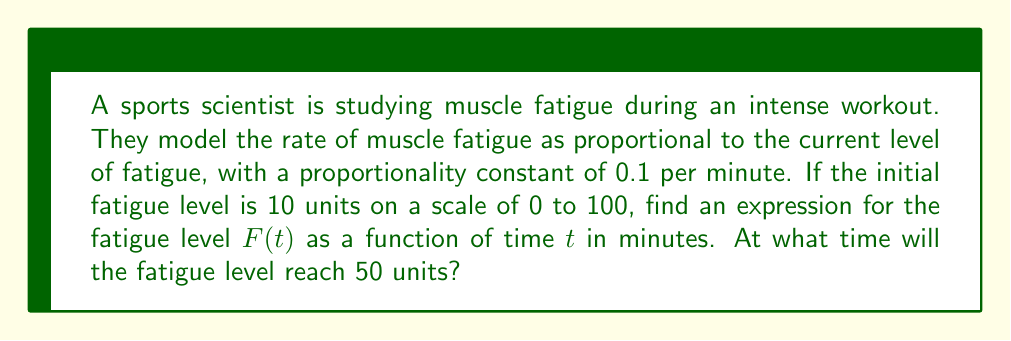What is the answer to this math problem? Let's approach this step-by-step:

1) The rate of change of fatigue is proportional to the current fatigue level. This can be expressed as a differential equation:

   $$\frac{dF}{dt} = kF$$

   where $k$ is the proportionality constant, given as 0.1 per minute.

2) We can rewrite this as:

   $$\frac{dF}{F} = 0.1 dt$$

3) Integrating both sides:

   $$\int \frac{dF}{F} = \int 0.1 dt$$

   $$\ln|F| = 0.1t + C$$

4) Taking the exponential of both sides:

   $$F = e^{0.1t + C} = e^C \cdot e^{0.1t}$$

5) Let $A = e^C$. Then our general solution is:

   $$F(t) = Ae^{0.1t}$$

6) To find $A$, we use the initial condition. At $t=0$, $F(0) = 10$:

   $$10 = Ae^{0.1(0)} = A$$

7) Therefore, our specific solution is:

   $$F(t) = 10e^{0.1t}$$

8) To find when the fatigue level reaches 50 units, we solve:

   $$50 = 10e^{0.1t}$$

   $$5 = e^{0.1t}$$

   $$\ln 5 = 0.1t$$

   $$t = \frac{\ln 5}{0.1} \approx 16.1 \text{ minutes}$$
Answer: The fatigue level as a function of time is $F(t) = 10e^{0.1t}$, where $t$ is in minutes. The fatigue level will reach 50 units after approximately 16.1 minutes. 